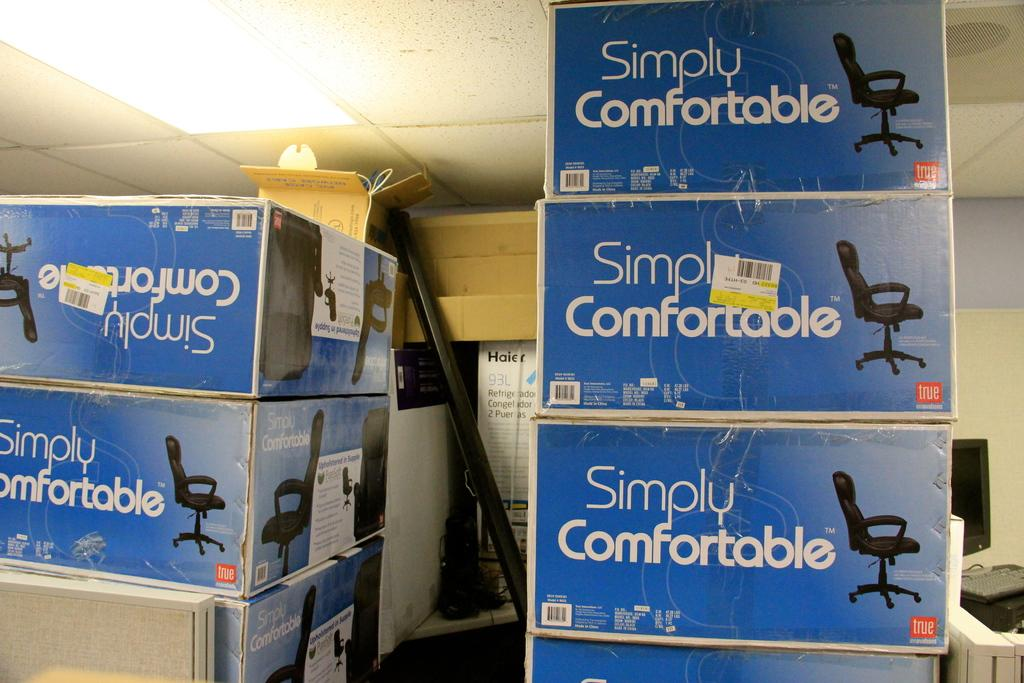<image>
Summarize the visual content of the image. Several boxes are stacked up that read "simply comfortable" 